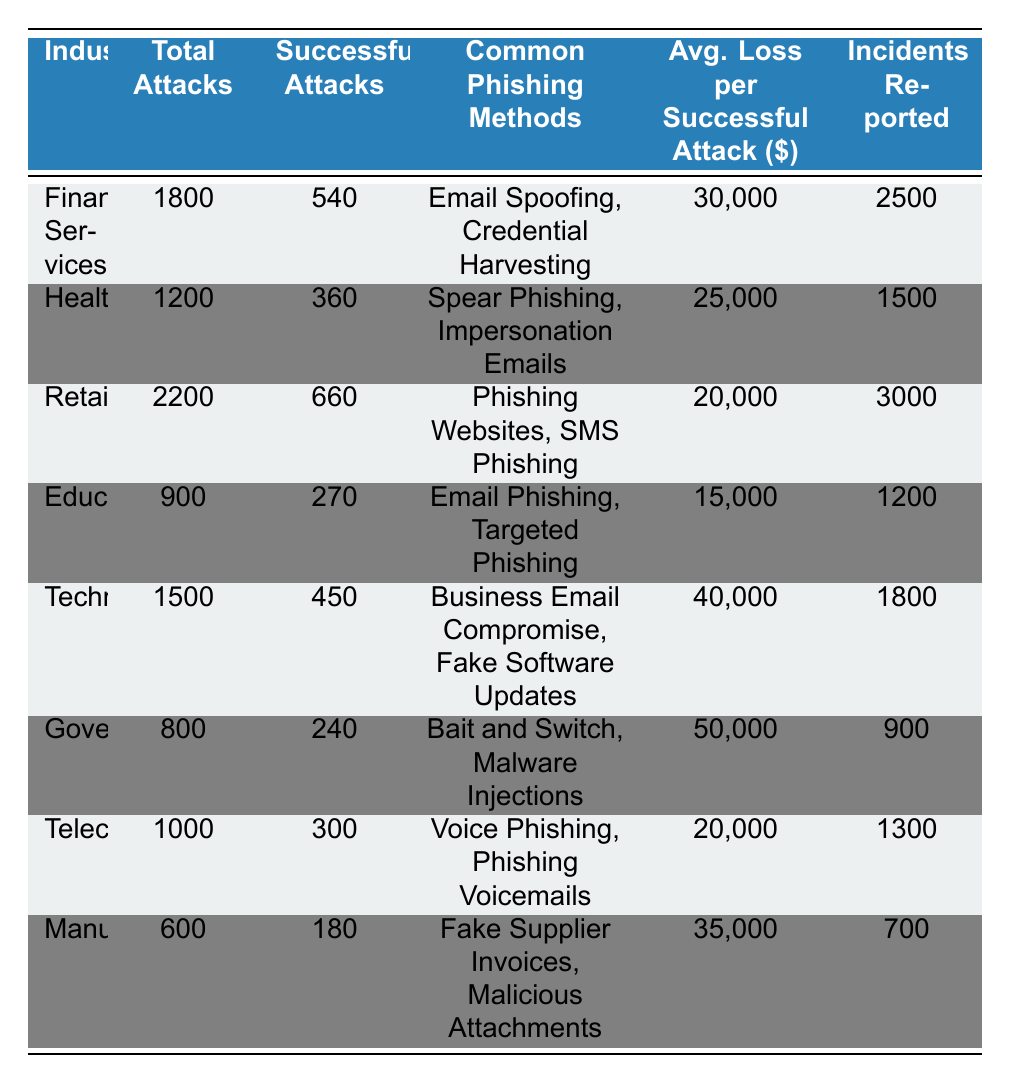What is the total number of phishing attacks in the Retail industry? The table states that the Retail industry had 2200 total phishing attacks.
Answer: 2200 How many successful attacks were recorded in the Financial Services industry? According to the table, the Financial Services industry reported 540 successful attacks.
Answer: 540 Which industry reported the highest average loss per successful attack? The Government industry reported the highest average loss of $50,000 per successful attack, as seen in the table.
Answer: Government What are the common phishing methods used in Healthcare? The table lists "Spear Phishing" and "Impersonation Emails" as common phishing methods for the Healthcare industry.
Answer: Spear Phishing, Impersonation Emails Calculate the total number of phishing attacks across all listed industries. Summing the total attacks: 1800 + 1200 + 2200 + 900 + 1500 + 800 + 1000 + 600 = 11500 total phishing attacks.
Answer: 11500 What is the percentage of successful attacks in the Technology industry? The Technology industry has 450 successful attacks out of 1500 total attacks. Calculating the percentage: (450/1500) * 100 = 30%.
Answer: 30% Which industry had the lowest number of incidents reported? The Manufacturing industry reported the lowest number of incidents at 700, according to the table.
Answer: Manufacturing If the Healthcare industry had 360 successful attacks, what is the average loss in total for those attacks? The average loss per successful attack in Healthcare is $25,000, multiplying this by successful attacks: 360 * 25,000 = $9,000,000.
Answer: $9,000,000 What is the difference between total attacks in Retail and Government? The Retail industry had 2200 total attacks and the Government industry had 800, so the difference is 2200 - 800 = 1400.
Answer: 1400 Is it true that Telecommunications had more successful attacks than Healthcare? The Telecommunications industry reported 300 successful attacks while Healthcare reported 360, thus it is false that Telecommunications had more.
Answer: False 